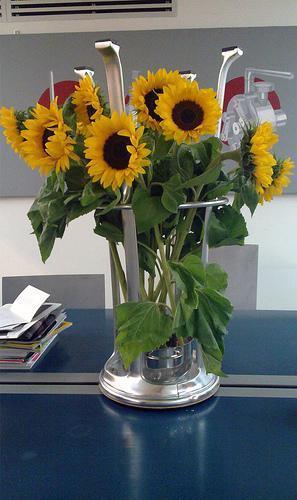How many sunflowers?
Give a very brief answer. 8. How many vases can you see?
Give a very brief answer. 2. How many potted plants can be seen?
Give a very brief answer. 1. 